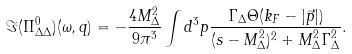<formula> <loc_0><loc_0><loc_500><loc_500>\Im ( \Pi ^ { 0 } _ { \Delta \Delta } ) ( \omega , q ) = - \frac { 4 M _ { \Delta } ^ { 2 } } { 9 \pi ^ { 3 } } \int d ^ { 3 } p \frac { \Gamma _ { \Delta } \Theta ( k _ { F } - | \vec { p } | ) } { ( s - M _ { \Delta } ^ { 2 } ) ^ { 2 } + M _ { \Delta } ^ { 2 } \Gamma _ { \Delta } ^ { 2 } } .</formula> 